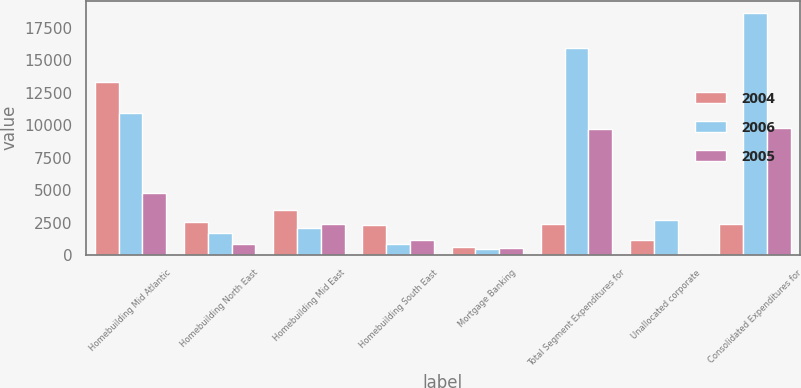Convert chart. <chart><loc_0><loc_0><loc_500><loc_500><stacked_bar_chart><ecel><fcel>Homebuilding Mid Atlantic<fcel>Homebuilding North East<fcel>Homebuilding Mid East<fcel>Homebuilding South East<fcel>Mortgage Banking<fcel>Total Segment Expenditures for<fcel>Unallocated corporate<fcel>Consolidated Expenditures for<nl><fcel>2004<fcel>13355<fcel>2545<fcel>3483<fcel>2311<fcel>612<fcel>2361.5<fcel>1125<fcel>2361.5<nl><fcel>2006<fcel>10938<fcel>1719<fcel>2065<fcel>808<fcel>448<fcel>15978<fcel>2692<fcel>18670<nl><fcel>2005<fcel>4768<fcel>836<fcel>2412<fcel>1144<fcel>513<fcel>9673<fcel>88<fcel>9761<nl></chart> 